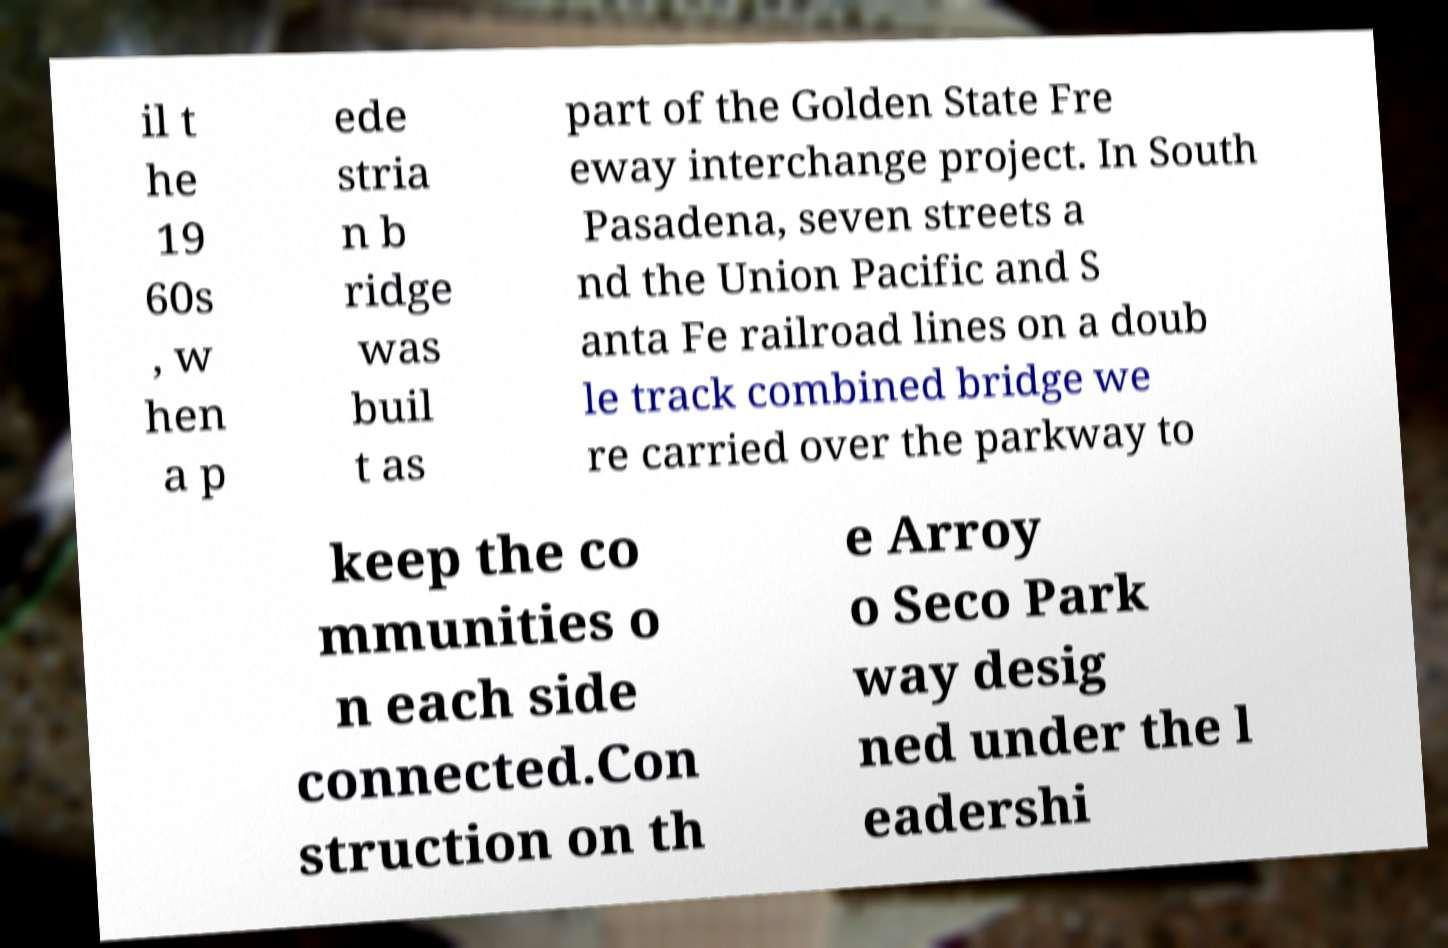What messages or text are displayed in this image? I need them in a readable, typed format. il t he 19 60s , w hen a p ede stria n b ridge was buil t as part of the Golden State Fre eway interchange project. In South Pasadena, seven streets a nd the Union Pacific and S anta Fe railroad lines on a doub le track combined bridge we re carried over the parkway to keep the co mmunities o n each side connected.Con struction on th e Arroy o Seco Park way desig ned under the l eadershi 